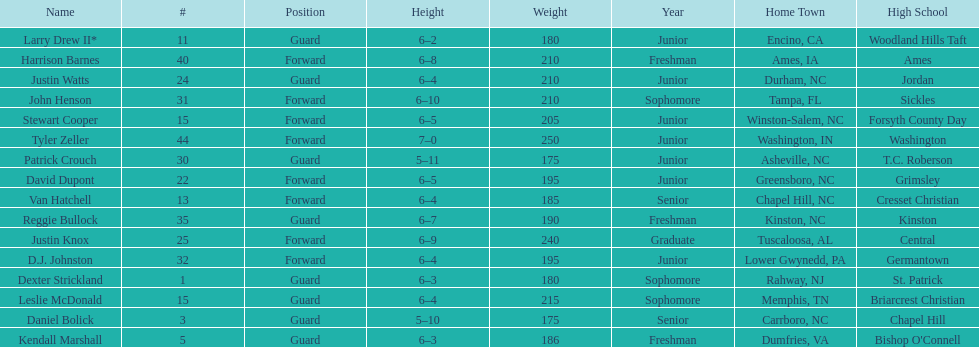How many players are not a junior? 9. 